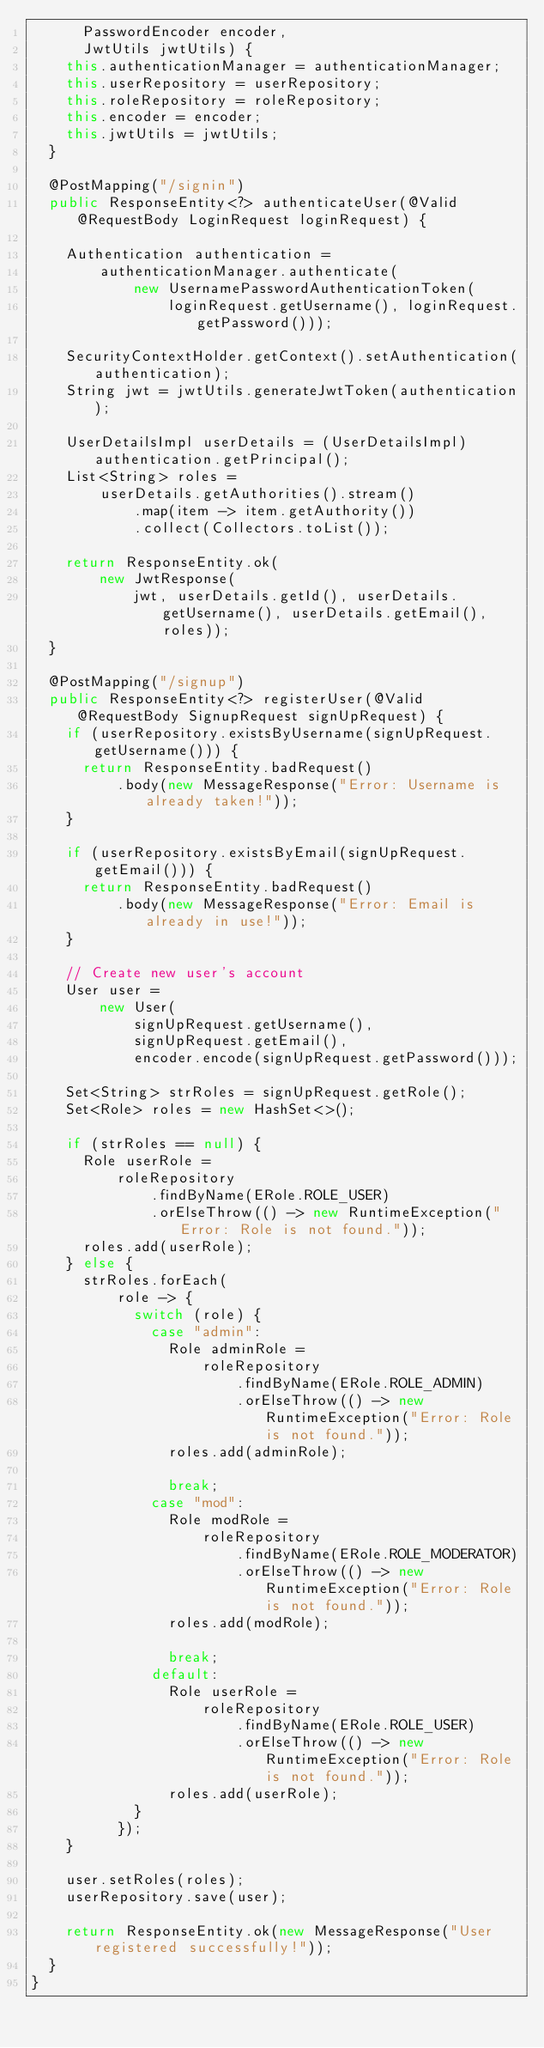<code> <loc_0><loc_0><loc_500><loc_500><_Java_>      PasswordEncoder encoder,
      JwtUtils jwtUtils) {
    this.authenticationManager = authenticationManager;
    this.userRepository = userRepository;
    this.roleRepository = roleRepository;
    this.encoder = encoder;
    this.jwtUtils = jwtUtils;
  }

  @PostMapping("/signin")
  public ResponseEntity<?> authenticateUser(@Valid @RequestBody LoginRequest loginRequest) {

    Authentication authentication =
        authenticationManager.authenticate(
            new UsernamePasswordAuthenticationToken(
                loginRequest.getUsername(), loginRequest.getPassword()));

    SecurityContextHolder.getContext().setAuthentication(authentication);
    String jwt = jwtUtils.generateJwtToken(authentication);

    UserDetailsImpl userDetails = (UserDetailsImpl) authentication.getPrincipal();
    List<String> roles =
        userDetails.getAuthorities().stream()
            .map(item -> item.getAuthority())
            .collect(Collectors.toList());

    return ResponseEntity.ok(
        new JwtResponse(
            jwt, userDetails.getId(), userDetails.getUsername(), userDetails.getEmail(), roles));
  }

  @PostMapping("/signup")
  public ResponseEntity<?> registerUser(@Valid @RequestBody SignupRequest signUpRequest) {
    if (userRepository.existsByUsername(signUpRequest.getUsername())) {
      return ResponseEntity.badRequest()
          .body(new MessageResponse("Error: Username is already taken!"));
    }

    if (userRepository.existsByEmail(signUpRequest.getEmail())) {
      return ResponseEntity.badRequest()
          .body(new MessageResponse("Error: Email is already in use!"));
    }

    // Create new user's account
    User user =
        new User(
            signUpRequest.getUsername(),
            signUpRequest.getEmail(),
            encoder.encode(signUpRequest.getPassword()));

    Set<String> strRoles = signUpRequest.getRole();
    Set<Role> roles = new HashSet<>();

    if (strRoles == null) {
      Role userRole =
          roleRepository
              .findByName(ERole.ROLE_USER)
              .orElseThrow(() -> new RuntimeException("Error: Role is not found."));
      roles.add(userRole);
    } else {
      strRoles.forEach(
          role -> {
            switch (role) {
              case "admin":
                Role adminRole =
                    roleRepository
                        .findByName(ERole.ROLE_ADMIN)
                        .orElseThrow(() -> new RuntimeException("Error: Role is not found."));
                roles.add(adminRole);

                break;
              case "mod":
                Role modRole =
                    roleRepository
                        .findByName(ERole.ROLE_MODERATOR)
                        .orElseThrow(() -> new RuntimeException("Error: Role is not found."));
                roles.add(modRole);

                break;
              default:
                Role userRole =
                    roleRepository
                        .findByName(ERole.ROLE_USER)
                        .orElseThrow(() -> new RuntimeException("Error: Role is not found."));
                roles.add(userRole);
            }
          });
    }

    user.setRoles(roles);
    userRepository.save(user);

    return ResponseEntity.ok(new MessageResponse("User registered successfully!"));
  }
}
</code> 